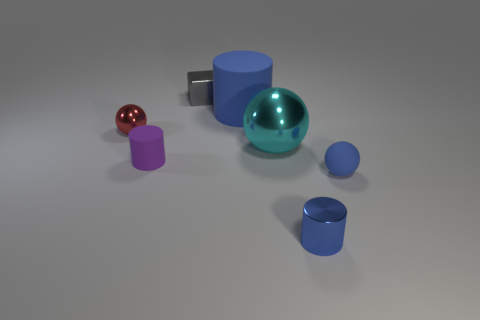Do the metal cylinder that is in front of the big blue thing and the large matte cylinder have the same color?
Your answer should be very brief. Yes. Does the small matte ball have the same color as the small shiny cylinder?
Provide a short and direct response. Yes. What shape is the tiny thing that is behind the blue thing that is behind the ball that is on the left side of the gray thing?
Your answer should be compact. Cube. Are there fewer purple things that are on the right side of the block than small shiny things that are on the right side of the red ball?
Give a very brief answer. Yes. There is a blue rubber thing that is behind the large sphere; is it the same shape as the metal object in front of the purple cylinder?
Make the answer very short. Yes. What shape is the big thing to the right of the blue cylinder that is to the left of the small shiny cylinder?
Make the answer very short. Sphere. The other cylinder that is the same color as the tiny metallic cylinder is what size?
Provide a short and direct response. Large. Is there a tiny yellow sphere that has the same material as the gray thing?
Ensure brevity in your answer.  No. What is the material of the tiny sphere that is to the left of the tiny blue shiny object?
Your answer should be very brief. Metal. What material is the small purple cylinder?
Make the answer very short. Rubber. 